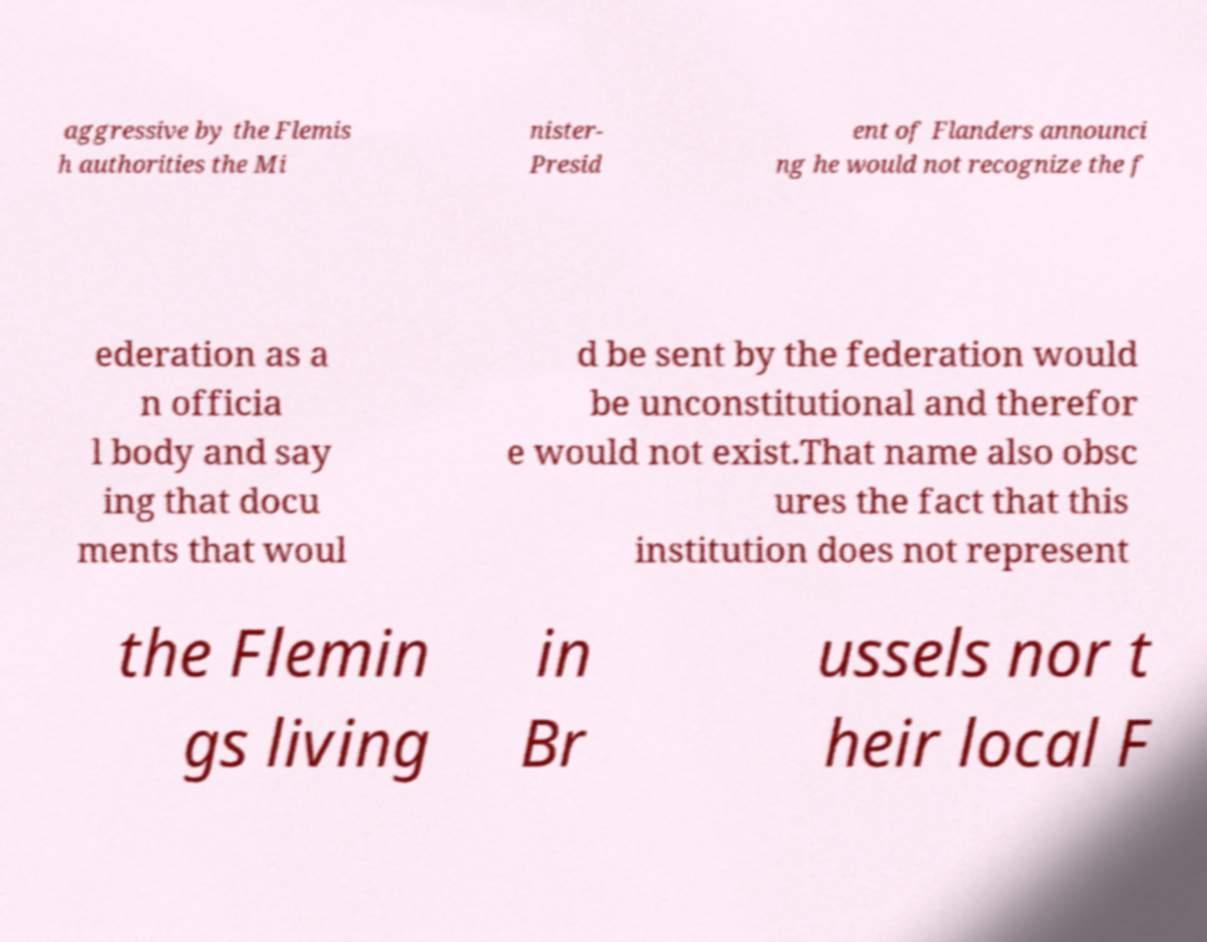Could you extract and type out the text from this image? aggressive by the Flemis h authorities the Mi nister- Presid ent of Flanders announci ng he would not recognize the f ederation as a n officia l body and say ing that docu ments that woul d be sent by the federation would be unconstitutional and therefor e would not exist.That name also obsc ures the fact that this institution does not represent the Flemin gs living in Br ussels nor t heir local F 